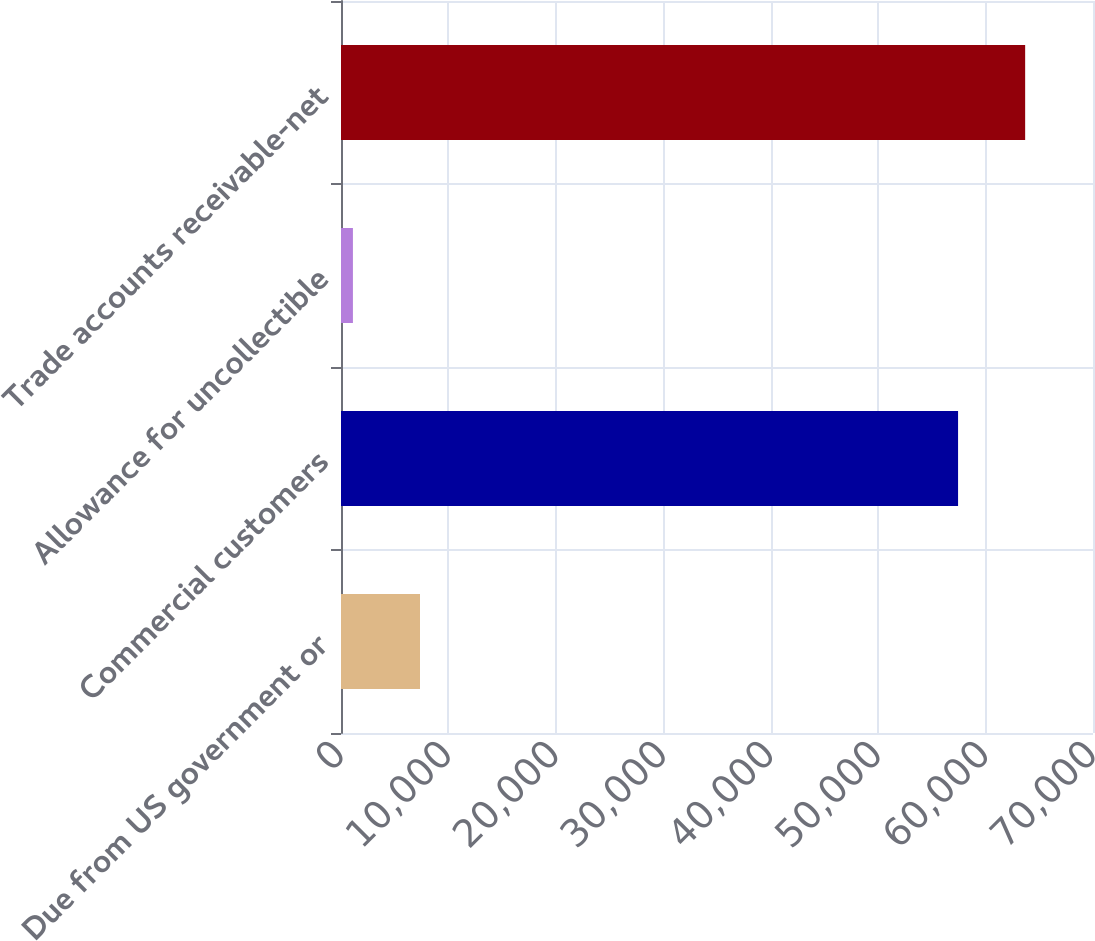<chart> <loc_0><loc_0><loc_500><loc_500><bar_chart><fcel>Due from US government or<fcel>Commercial customers<fcel>Allowance for uncollectible<fcel>Trade accounts receivable-net<nl><fcel>7354.4<fcel>57440<fcel>1110<fcel>63684.4<nl></chart> 